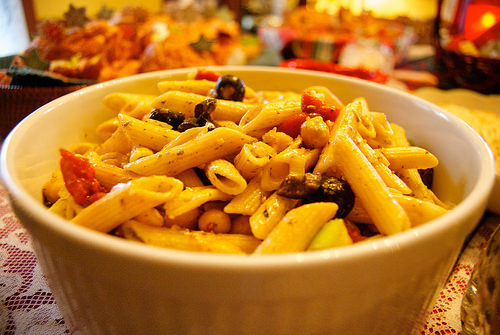<image>
Can you confirm if the noodles is in the bowl? Yes. The noodles is contained within or inside the bowl, showing a containment relationship. 